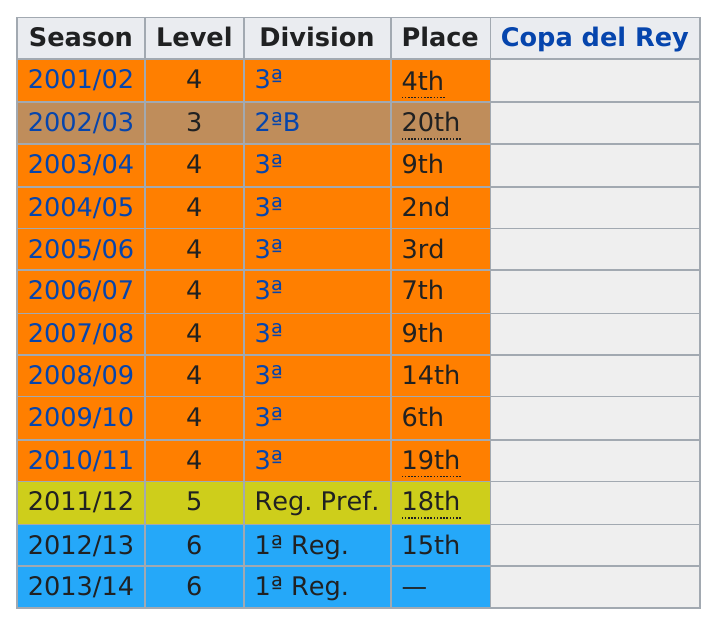Give some essential details in this illustration. The team immediately following the 2008/2009 season that finished in 6th place is... The team came in 9th place two times. The team remained in the 3A division for a total of eight seasons after the 2002/2003 season. In the 2005/06 season, the team finished in at least fifth place. The team's lowest placing during the period between 2001/02 and 2010/11 was 20th. 